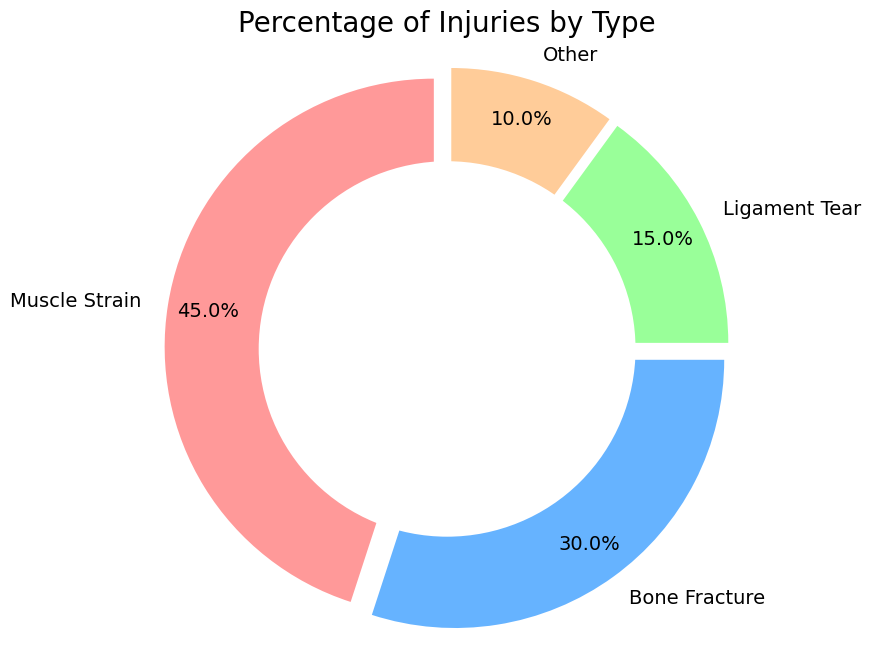What percentage of injuries are Muscle Strains compared to Bone Fractures? The ring chart shows that Muscle Strains account for 45% of injuries, while Bone Fractures account for 30%. Comparing these two percentages, Muscle Strains are higher than Bone Fractures.
Answer: 45% vs 30% Which type of injury is the least common? By observing the percentages labeled on the ring chart, Ligament Tears account for the lowest percentage of injuries at 15%. The 'Other' category also has a lower percentage at 10%.
Answer: Other (10%) What is the combined percentage of Muscle Strains and Ligament Tears? The ring chart shows Muscle Strains as 45% and Ligament Tears as 15%. Adding these percentages together, 45% + 15% equals 60%.
Answer: 60% How does the percentage of Bone Fractures compare to the combined percentage of Ligament Tears and Other injuries? Bone Fractures account for 30%. Ligament Tears and Other injuries together are 15% + 10%, which equals 25%. So, Bone Fractures (30%) are higher than the combined percentage of Ligament Tears and Other injuries (25%).
Answer: 30% vs 25% What color represents Muscle Strains on the ring chart? Observing the color coding in the chart, Muscle Strains are represented by the color red.
Answer: Red What is the difference in percentage between Muscle Strains and Ligament Tears? The chart shows Muscle Strains at 45% and Ligament Tears at 15%. Subtracting these, 45% - 15%, we get a difference of 30%.
Answer: 30% If 2000 injuries were recorded, how many of these would be Bone Fractures? Bone Fractures account for 30% of the injuries. Calculating 30% of 2000, we multiply 0.30 by 2000 to get 600.
Answer: 600 If 'Other' injuries increased by 5%, what would be the new percentage for this category? The current percentage for 'Other' injuries is 10%. Adding 5% to this, 10% + 5%, the new percentage would be 15%.
Answer: 15% Which injury type is represented by the blue color in the chart? Observing the color coding in the chart, Bone Fractures are represented by the color blue.
Answer: Bone Fractures 